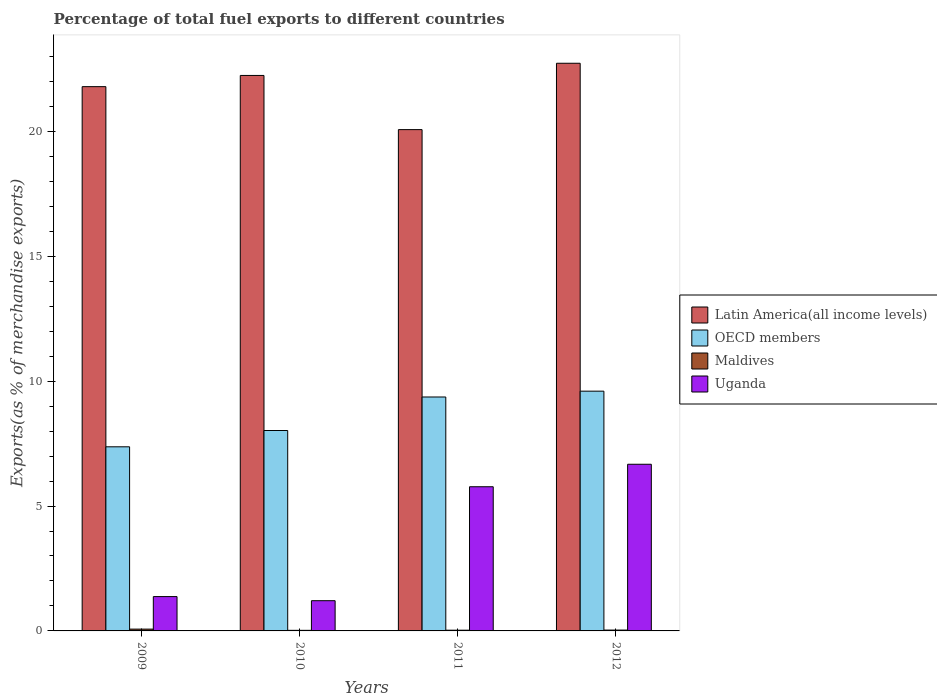How many groups of bars are there?
Keep it short and to the point. 4. Are the number of bars per tick equal to the number of legend labels?
Your answer should be compact. Yes. Are the number of bars on each tick of the X-axis equal?
Give a very brief answer. Yes. How many bars are there on the 4th tick from the left?
Provide a succinct answer. 4. What is the percentage of exports to different countries in OECD members in 2012?
Offer a terse response. 9.6. Across all years, what is the maximum percentage of exports to different countries in Maldives?
Provide a succinct answer. 0.07. Across all years, what is the minimum percentage of exports to different countries in OECD members?
Provide a succinct answer. 7.37. In which year was the percentage of exports to different countries in Latin America(all income levels) maximum?
Provide a short and direct response. 2012. In which year was the percentage of exports to different countries in Latin America(all income levels) minimum?
Offer a very short reply. 2011. What is the total percentage of exports to different countries in Latin America(all income levels) in the graph?
Provide a short and direct response. 86.84. What is the difference between the percentage of exports to different countries in OECD members in 2010 and that in 2011?
Provide a short and direct response. -1.34. What is the difference between the percentage of exports to different countries in Latin America(all income levels) in 2011 and the percentage of exports to different countries in Maldives in 2012?
Make the answer very short. 20.04. What is the average percentage of exports to different countries in Uganda per year?
Ensure brevity in your answer.  3.76. In the year 2011, what is the difference between the percentage of exports to different countries in OECD members and percentage of exports to different countries in Uganda?
Keep it short and to the point. 3.59. In how many years, is the percentage of exports to different countries in OECD members greater than 18 %?
Provide a succinct answer. 0. What is the ratio of the percentage of exports to different countries in Maldives in 2010 to that in 2011?
Make the answer very short. 0.8. Is the difference between the percentage of exports to different countries in OECD members in 2011 and 2012 greater than the difference between the percentage of exports to different countries in Uganda in 2011 and 2012?
Provide a short and direct response. Yes. What is the difference between the highest and the second highest percentage of exports to different countries in OECD members?
Your answer should be very brief. 0.23. What is the difference between the highest and the lowest percentage of exports to different countries in Uganda?
Keep it short and to the point. 5.46. In how many years, is the percentage of exports to different countries in Uganda greater than the average percentage of exports to different countries in Uganda taken over all years?
Make the answer very short. 2. What does the 2nd bar from the right in 2010 represents?
Provide a succinct answer. Maldives. How many bars are there?
Your response must be concise. 16. Are all the bars in the graph horizontal?
Give a very brief answer. No. Does the graph contain grids?
Provide a succinct answer. No. What is the title of the graph?
Make the answer very short. Percentage of total fuel exports to different countries. Does "Guam" appear as one of the legend labels in the graph?
Keep it short and to the point. No. What is the label or title of the X-axis?
Provide a short and direct response. Years. What is the label or title of the Y-axis?
Make the answer very short. Exports(as % of merchandise exports). What is the Exports(as % of merchandise exports) in Latin America(all income levels) in 2009?
Make the answer very short. 21.79. What is the Exports(as % of merchandise exports) of OECD members in 2009?
Your answer should be very brief. 7.37. What is the Exports(as % of merchandise exports) of Maldives in 2009?
Give a very brief answer. 0.07. What is the Exports(as % of merchandise exports) of Uganda in 2009?
Offer a very short reply. 1.38. What is the Exports(as % of merchandise exports) of Latin America(all income levels) in 2010?
Make the answer very short. 22.24. What is the Exports(as % of merchandise exports) of OECD members in 2010?
Offer a terse response. 8.02. What is the Exports(as % of merchandise exports) of Maldives in 2010?
Your response must be concise. 0.02. What is the Exports(as % of merchandise exports) of Uganda in 2010?
Offer a terse response. 1.21. What is the Exports(as % of merchandise exports) of Latin America(all income levels) in 2011?
Keep it short and to the point. 20.07. What is the Exports(as % of merchandise exports) of OECD members in 2011?
Give a very brief answer. 9.37. What is the Exports(as % of merchandise exports) of Maldives in 2011?
Make the answer very short. 0.03. What is the Exports(as % of merchandise exports) of Uganda in 2011?
Provide a short and direct response. 5.77. What is the Exports(as % of merchandise exports) of Latin America(all income levels) in 2012?
Give a very brief answer. 22.73. What is the Exports(as % of merchandise exports) of OECD members in 2012?
Your response must be concise. 9.6. What is the Exports(as % of merchandise exports) in Maldives in 2012?
Keep it short and to the point. 0.03. What is the Exports(as % of merchandise exports) of Uganda in 2012?
Give a very brief answer. 6.67. Across all years, what is the maximum Exports(as % of merchandise exports) of Latin America(all income levels)?
Your answer should be very brief. 22.73. Across all years, what is the maximum Exports(as % of merchandise exports) in OECD members?
Provide a short and direct response. 9.6. Across all years, what is the maximum Exports(as % of merchandise exports) in Maldives?
Your answer should be very brief. 0.07. Across all years, what is the maximum Exports(as % of merchandise exports) in Uganda?
Your answer should be compact. 6.67. Across all years, what is the minimum Exports(as % of merchandise exports) in Latin America(all income levels)?
Offer a terse response. 20.07. Across all years, what is the minimum Exports(as % of merchandise exports) in OECD members?
Your answer should be compact. 7.37. Across all years, what is the minimum Exports(as % of merchandise exports) of Maldives?
Make the answer very short. 0.02. Across all years, what is the minimum Exports(as % of merchandise exports) of Uganda?
Your answer should be compact. 1.21. What is the total Exports(as % of merchandise exports) in Latin America(all income levels) in the graph?
Give a very brief answer. 86.84. What is the total Exports(as % of merchandise exports) in OECD members in the graph?
Your response must be concise. 34.36. What is the total Exports(as % of merchandise exports) of Maldives in the graph?
Give a very brief answer. 0.16. What is the total Exports(as % of merchandise exports) in Uganda in the graph?
Provide a short and direct response. 15.03. What is the difference between the Exports(as % of merchandise exports) in Latin America(all income levels) in 2009 and that in 2010?
Give a very brief answer. -0.45. What is the difference between the Exports(as % of merchandise exports) in OECD members in 2009 and that in 2010?
Offer a very short reply. -0.65. What is the difference between the Exports(as % of merchandise exports) in Maldives in 2009 and that in 2010?
Provide a short and direct response. 0.05. What is the difference between the Exports(as % of merchandise exports) of Uganda in 2009 and that in 2010?
Offer a terse response. 0.17. What is the difference between the Exports(as % of merchandise exports) of Latin America(all income levels) in 2009 and that in 2011?
Keep it short and to the point. 1.72. What is the difference between the Exports(as % of merchandise exports) in OECD members in 2009 and that in 2011?
Keep it short and to the point. -1.99. What is the difference between the Exports(as % of merchandise exports) of Maldives in 2009 and that in 2011?
Ensure brevity in your answer.  0.04. What is the difference between the Exports(as % of merchandise exports) in Uganda in 2009 and that in 2011?
Ensure brevity in your answer.  -4.4. What is the difference between the Exports(as % of merchandise exports) in Latin America(all income levels) in 2009 and that in 2012?
Your answer should be compact. -0.94. What is the difference between the Exports(as % of merchandise exports) of OECD members in 2009 and that in 2012?
Provide a succinct answer. -2.23. What is the difference between the Exports(as % of merchandise exports) in Maldives in 2009 and that in 2012?
Provide a succinct answer. 0.04. What is the difference between the Exports(as % of merchandise exports) in Uganda in 2009 and that in 2012?
Keep it short and to the point. -5.3. What is the difference between the Exports(as % of merchandise exports) of Latin America(all income levels) in 2010 and that in 2011?
Give a very brief answer. 2.17. What is the difference between the Exports(as % of merchandise exports) of OECD members in 2010 and that in 2011?
Keep it short and to the point. -1.34. What is the difference between the Exports(as % of merchandise exports) in Maldives in 2010 and that in 2011?
Offer a terse response. -0.01. What is the difference between the Exports(as % of merchandise exports) in Uganda in 2010 and that in 2011?
Provide a short and direct response. -4.56. What is the difference between the Exports(as % of merchandise exports) of Latin America(all income levels) in 2010 and that in 2012?
Your answer should be compact. -0.49. What is the difference between the Exports(as % of merchandise exports) in OECD members in 2010 and that in 2012?
Provide a succinct answer. -1.58. What is the difference between the Exports(as % of merchandise exports) in Maldives in 2010 and that in 2012?
Your answer should be very brief. -0.01. What is the difference between the Exports(as % of merchandise exports) of Uganda in 2010 and that in 2012?
Ensure brevity in your answer.  -5.46. What is the difference between the Exports(as % of merchandise exports) of Latin America(all income levels) in 2011 and that in 2012?
Offer a very short reply. -2.66. What is the difference between the Exports(as % of merchandise exports) of OECD members in 2011 and that in 2012?
Your answer should be very brief. -0.23. What is the difference between the Exports(as % of merchandise exports) of Maldives in 2011 and that in 2012?
Offer a very short reply. -0.01. What is the difference between the Exports(as % of merchandise exports) in Uganda in 2011 and that in 2012?
Ensure brevity in your answer.  -0.9. What is the difference between the Exports(as % of merchandise exports) in Latin America(all income levels) in 2009 and the Exports(as % of merchandise exports) in OECD members in 2010?
Keep it short and to the point. 13.77. What is the difference between the Exports(as % of merchandise exports) of Latin America(all income levels) in 2009 and the Exports(as % of merchandise exports) of Maldives in 2010?
Provide a short and direct response. 21.77. What is the difference between the Exports(as % of merchandise exports) of Latin America(all income levels) in 2009 and the Exports(as % of merchandise exports) of Uganda in 2010?
Offer a terse response. 20.58. What is the difference between the Exports(as % of merchandise exports) in OECD members in 2009 and the Exports(as % of merchandise exports) in Maldives in 2010?
Your response must be concise. 7.35. What is the difference between the Exports(as % of merchandise exports) of OECD members in 2009 and the Exports(as % of merchandise exports) of Uganda in 2010?
Provide a succinct answer. 6.16. What is the difference between the Exports(as % of merchandise exports) of Maldives in 2009 and the Exports(as % of merchandise exports) of Uganda in 2010?
Offer a very short reply. -1.14. What is the difference between the Exports(as % of merchandise exports) in Latin America(all income levels) in 2009 and the Exports(as % of merchandise exports) in OECD members in 2011?
Your answer should be compact. 12.43. What is the difference between the Exports(as % of merchandise exports) in Latin America(all income levels) in 2009 and the Exports(as % of merchandise exports) in Maldives in 2011?
Offer a terse response. 21.76. What is the difference between the Exports(as % of merchandise exports) of Latin America(all income levels) in 2009 and the Exports(as % of merchandise exports) of Uganda in 2011?
Offer a very short reply. 16.02. What is the difference between the Exports(as % of merchandise exports) in OECD members in 2009 and the Exports(as % of merchandise exports) in Maldives in 2011?
Make the answer very short. 7.34. What is the difference between the Exports(as % of merchandise exports) in OECD members in 2009 and the Exports(as % of merchandise exports) in Uganda in 2011?
Ensure brevity in your answer.  1.6. What is the difference between the Exports(as % of merchandise exports) of Maldives in 2009 and the Exports(as % of merchandise exports) of Uganda in 2011?
Your answer should be very brief. -5.7. What is the difference between the Exports(as % of merchandise exports) of Latin America(all income levels) in 2009 and the Exports(as % of merchandise exports) of OECD members in 2012?
Give a very brief answer. 12.19. What is the difference between the Exports(as % of merchandise exports) of Latin America(all income levels) in 2009 and the Exports(as % of merchandise exports) of Maldives in 2012?
Provide a succinct answer. 21.76. What is the difference between the Exports(as % of merchandise exports) of Latin America(all income levels) in 2009 and the Exports(as % of merchandise exports) of Uganda in 2012?
Offer a terse response. 15.12. What is the difference between the Exports(as % of merchandise exports) in OECD members in 2009 and the Exports(as % of merchandise exports) in Maldives in 2012?
Offer a very short reply. 7.34. What is the difference between the Exports(as % of merchandise exports) in OECD members in 2009 and the Exports(as % of merchandise exports) in Uganda in 2012?
Keep it short and to the point. 0.7. What is the difference between the Exports(as % of merchandise exports) in Maldives in 2009 and the Exports(as % of merchandise exports) in Uganda in 2012?
Offer a terse response. -6.6. What is the difference between the Exports(as % of merchandise exports) in Latin America(all income levels) in 2010 and the Exports(as % of merchandise exports) in OECD members in 2011?
Your answer should be very brief. 12.87. What is the difference between the Exports(as % of merchandise exports) in Latin America(all income levels) in 2010 and the Exports(as % of merchandise exports) in Maldives in 2011?
Keep it short and to the point. 22.21. What is the difference between the Exports(as % of merchandise exports) of Latin America(all income levels) in 2010 and the Exports(as % of merchandise exports) of Uganda in 2011?
Your answer should be compact. 16.47. What is the difference between the Exports(as % of merchandise exports) of OECD members in 2010 and the Exports(as % of merchandise exports) of Maldives in 2011?
Offer a terse response. 8. What is the difference between the Exports(as % of merchandise exports) of OECD members in 2010 and the Exports(as % of merchandise exports) of Uganda in 2011?
Your response must be concise. 2.25. What is the difference between the Exports(as % of merchandise exports) in Maldives in 2010 and the Exports(as % of merchandise exports) in Uganda in 2011?
Make the answer very short. -5.75. What is the difference between the Exports(as % of merchandise exports) in Latin America(all income levels) in 2010 and the Exports(as % of merchandise exports) in OECD members in 2012?
Your answer should be very brief. 12.64. What is the difference between the Exports(as % of merchandise exports) of Latin America(all income levels) in 2010 and the Exports(as % of merchandise exports) of Maldives in 2012?
Keep it short and to the point. 22.21. What is the difference between the Exports(as % of merchandise exports) of Latin America(all income levels) in 2010 and the Exports(as % of merchandise exports) of Uganda in 2012?
Your response must be concise. 15.57. What is the difference between the Exports(as % of merchandise exports) of OECD members in 2010 and the Exports(as % of merchandise exports) of Maldives in 2012?
Give a very brief answer. 7.99. What is the difference between the Exports(as % of merchandise exports) of OECD members in 2010 and the Exports(as % of merchandise exports) of Uganda in 2012?
Keep it short and to the point. 1.35. What is the difference between the Exports(as % of merchandise exports) in Maldives in 2010 and the Exports(as % of merchandise exports) in Uganda in 2012?
Provide a succinct answer. -6.65. What is the difference between the Exports(as % of merchandise exports) of Latin America(all income levels) in 2011 and the Exports(as % of merchandise exports) of OECD members in 2012?
Your response must be concise. 10.47. What is the difference between the Exports(as % of merchandise exports) of Latin America(all income levels) in 2011 and the Exports(as % of merchandise exports) of Maldives in 2012?
Your answer should be very brief. 20.04. What is the difference between the Exports(as % of merchandise exports) of Latin America(all income levels) in 2011 and the Exports(as % of merchandise exports) of Uganda in 2012?
Offer a very short reply. 13.4. What is the difference between the Exports(as % of merchandise exports) of OECD members in 2011 and the Exports(as % of merchandise exports) of Maldives in 2012?
Provide a short and direct response. 9.33. What is the difference between the Exports(as % of merchandise exports) in OECD members in 2011 and the Exports(as % of merchandise exports) in Uganda in 2012?
Provide a short and direct response. 2.69. What is the difference between the Exports(as % of merchandise exports) of Maldives in 2011 and the Exports(as % of merchandise exports) of Uganda in 2012?
Offer a very short reply. -6.64. What is the average Exports(as % of merchandise exports) of Latin America(all income levels) per year?
Your answer should be very brief. 21.71. What is the average Exports(as % of merchandise exports) in OECD members per year?
Your response must be concise. 8.59. What is the average Exports(as % of merchandise exports) of Maldives per year?
Ensure brevity in your answer.  0.04. What is the average Exports(as % of merchandise exports) in Uganda per year?
Provide a succinct answer. 3.76. In the year 2009, what is the difference between the Exports(as % of merchandise exports) in Latin America(all income levels) and Exports(as % of merchandise exports) in OECD members?
Provide a succinct answer. 14.42. In the year 2009, what is the difference between the Exports(as % of merchandise exports) in Latin America(all income levels) and Exports(as % of merchandise exports) in Maldives?
Your response must be concise. 21.72. In the year 2009, what is the difference between the Exports(as % of merchandise exports) in Latin America(all income levels) and Exports(as % of merchandise exports) in Uganda?
Keep it short and to the point. 20.42. In the year 2009, what is the difference between the Exports(as % of merchandise exports) in OECD members and Exports(as % of merchandise exports) in Maldives?
Your answer should be very brief. 7.3. In the year 2009, what is the difference between the Exports(as % of merchandise exports) of OECD members and Exports(as % of merchandise exports) of Uganda?
Offer a terse response. 6. In the year 2009, what is the difference between the Exports(as % of merchandise exports) in Maldives and Exports(as % of merchandise exports) in Uganda?
Keep it short and to the point. -1.3. In the year 2010, what is the difference between the Exports(as % of merchandise exports) in Latin America(all income levels) and Exports(as % of merchandise exports) in OECD members?
Ensure brevity in your answer.  14.22. In the year 2010, what is the difference between the Exports(as % of merchandise exports) of Latin America(all income levels) and Exports(as % of merchandise exports) of Maldives?
Ensure brevity in your answer.  22.22. In the year 2010, what is the difference between the Exports(as % of merchandise exports) in Latin America(all income levels) and Exports(as % of merchandise exports) in Uganda?
Offer a very short reply. 21.03. In the year 2010, what is the difference between the Exports(as % of merchandise exports) of OECD members and Exports(as % of merchandise exports) of Maldives?
Make the answer very short. 8. In the year 2010, what is the difference between the Exports(as % of merchandise exports) of OECD members and Exports(as % of merchandise exports) of Uganda?
Provide a short and direct response. 6.82. In the year 2010, what is the difference between the Exports(as % of merchandise exports) in Maldives and Exports(as % of merchandise exports) in Uganda?
Make the answer very short. -1.19. In the year 2011, what is the difference between the Exports(as % of merchandise exports) in Latin America(all income levels) and Exports(as % of merchandise exports) in OECD members?
Provide a succinct answer. 10.71. In the year 2011, what is the difference between the Exports(as % of merchandise exports) in Latin America(all income levels) and Exports(as % of merchandise exports) in Maldives?
Provide a succinct answer. 20.04. In the year 2011, what is the difference between the Exports(as % of merchandise exports) in Latin America(all income levels) and Exports(as % of merchandise exports) in Uganda?
Your answer should be very brief. 14.3. In the year 2011, what is the difference between the Exports(as % of merchandise exports) in OECD members and Exports(as % of merchandise exports) in Maldives?
Your answer should be compact. 9.34. In the year 2011, what is the difference between the Exports(as % of merchandise exports) in OECD members and Exports(as % of merchandise exports) in Uganda?
Provide a succinct answer. 3.59. In the year 2011, what is the difference between the Exports(as % of merchandise exports) of Maldives and Exports(as % of merchandise exports) of Uganda?
Your response must be concise. -5.74. In the year 2012, what is the difference between the Exports(as % of merchandise exports) in Latin America(all income levels) and Exports(as % of merchandise exports) in OECD members?
Provide a short and direct response. 13.13. In the year 2012, what is the difference between the Exports(as % of merchandise exports) of Latin America(all income levels) and Exports(as % of merchandise exports) of Maldives?
Provide a short and direct response. 22.7. In the year 2012, what is the difference between the Exports(as % of merchandise exports) in Latin America(all income levels) and Exports(as % of merchandise exports) in Uganda?
Offer a terse response. 16.06. In the year 2012, what is the difference between the Exports(as % of merchandise exports) of OECD members and Exports(as % of merchandise exports) of Maldives?
Provide a succinct answer. 9.57. In the year 2012, what is the difference between the Exports(as % of merchandise exports) of OECD members and Exports(as % of merchandise exports) of Uganda?
Provide a succinct answer. 2.93. In the year 2012, what is the difference between the Exports(as % of merchandise exports) of Maldives and Exports(as % of merchandise exports) of Uganda?
Give a very brief answer. -6.64. What is the ratio of the Exports(as % of merchandise exports) of Latin America(all income levels) in 2009 to that in 2010?
Your answer should be very brief. 0.98. What is the ratio of the Exports(as % of merchandise exports) in OECD members in 2009 to that in 2010?
Provide a short and direct response. 0.92. What is the ratio of the Exports(as % of merchandise exports) of Maldives in 2009 to that in 2010?
Your answer should be compact. 3.12. What is the ratio of the Exports(as % of merchandise exports) of Uganda in 2009 to that in 2010?
Keep it short and to the point. 1.14. What is the ratio of the Exports(as % of merchandise exports) of Latin America(all income levels) in 2009 to that in 2011?
Provide a short and direct response. 1.09. What is the ratio of the Exports(as % of merchandise exports) in OECD members in 2009 to that in 2011?
Your answer should be very brief. 0.79. What is the ratio of the Exports(as % of merchandise exports) in Maldives in 2009 to that in 2011?
Give a very brief answer. 2.48. What is the ratio of the Exports(as % of merchandise exports) of Uganda in 2009 to that in 2011?
Provide a succinct answer. 0.24. What is the ratio of the Exports(as % of merchandise exports) in Latin America(all income levels) in 2009 to that in 2012?
Provide a succinct answer. 0.96. What is the ratio of the Exports(as % of merchandise exports) in OECD members in 2009 to that in 2012?
Your answer should be very brief. 0.77. What is the ratio of the Exports(as % of merchandise exports) of Maldives in 2009 to that in 2012?
Your answer should be very brief. 2.11. What is the ratio of the Exports(as % of merchandise exports) in Uganda in 2009 to that in 2012?
Ensure brevity in your answer.  0.21. What is the ratio of the Exports(as % of merchandise exports) in Latin America(all income levels) in 2010 to that in 2011?
Ensure brevity in your answer.  1.11. What is the ratio of the Exports(as % of merchandise exports) of OECD members in 2010 to that in 2011?
Offer a very short reply. 0.86. What is the ratio of the Exports(as % of merchandise exports) of Maldives in 2010 to that in 2011?
Provide a short and direct response. 0.8. What is the ratio of the Exports(as % of merchandise exports) of Uganda in 2010 to that in 2011?
Offer a terse response. 0.21. What is the ratio of the Exports(as % of merchandise exports) of Latin America(all income levels) in 2010 to that in 2012?
Give a very brief answer. 0.98. What is the ratio of the Exports(as % of merchandise exports) in OECD members in 2010 to that in 2012?
Make the answer very short. 0.84. What is the ratio of the Exports(as % of merchandise exports) of Maldives in 2010 to that in 2012?
Give a very brief answer. 0.68. What is the ratio of the Exports(as % of merchandise exports) of Uganda in 2010 to that in 2012?
Provide a short and direct response. 0.18. What is the ratio of the Exports(as % of merchandise exports) of Latin America(all income levels) in 2011 to that in 2012?
Keep it short and to the point. 0.88. What is the ratio of the Exports(as % of merchandise exports) of OECD members in 2011 to that in 2012?
Your response must be concise. 0.98. What is the ratio of the Exports(as % of merchandise exports) of Maldives in 2011 to that in 2012?
Offer a very short reply. 0.85. What is the ratio of the Exports(as % of merchandise exports) of Uganda in 2011 to that in 2012?
Your response must be concise. 0.87. What is the difference between the highest and the second highest Exports(as % of merchandise exports) in Latin America(all income levels)?
Ensure brevity in your answer.  0.49. What is the difference between the highest and the second highest Exports(as % of merchandise exports) in OECD members?
Keep it short and to the point. 0.23. What is the difference between the highest and the second highest Exports(as % of merchandise exports) of Maldives?
Offer a very short reply. 0.04. What is the difference between the highest and the second highest Exports(as % of merchandise exports) of Uganda?
Your answer should be compact. 0.9. What is the difference between the highest and the lowest Exports(as % of merchandise exports) of Latin America(all income levels)?
Give a very brief answer. 2.66. What is the difference between the highest and the lowest Exports(as % of merchandise exports) of OECD members?
Keep it short and to the point. 2.23. What is the difference between the highest and the lowest Exports(as % of merchandise exports) in Maldives?
Ensure brevity in your answer.  0.05. What is the difference between the highest and the lowest Exports(as % of merchandise exports) of Uganda?
Give a very brief answer. 5.46. 